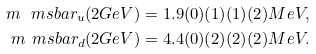<formula> <loc_0><loc_0><loc_500><loc_500>m ^ { \ } m s b a r _ { u } ( 2 G e V ) & = 1 . 9 ( 0 ) ( 1 ) ( 1 ) ( 2 ) M e V , \\ m ^ { \ } m s b a r _ { d } ( 2 G e V ) & = 4 . 4 ( 0 ) ( 2 ) ( 2 ) ( 2 ) M e V .</formula> 